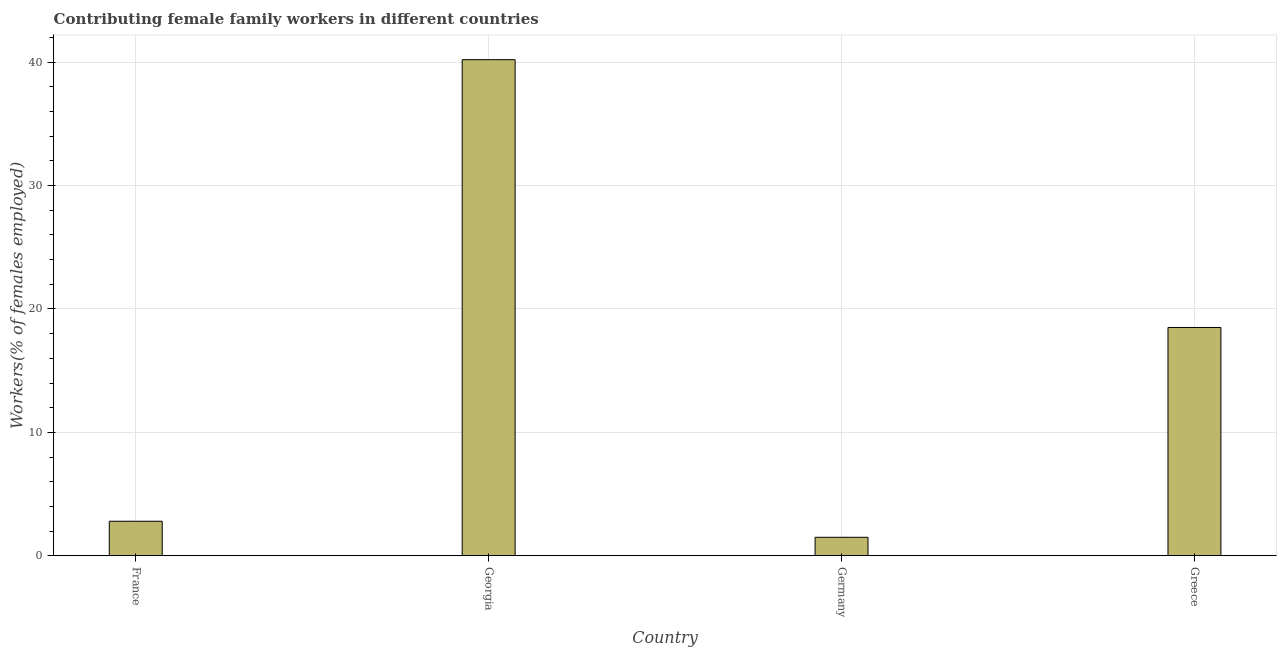What is the title of the graph?
Your response must be concise. Contributing female family workers in different countries. What is the label or title of the X-axis?
Make the answer very short. Country. What is the label or title of the Y-axis?
Give a very brief answer. Workers(% of females employed). Across all countries, what is the maximum contributing female family workers?
Offer a very short reply. 40.2. Across all countries, what is the minimum contributing female family workers?
Provide a short and direct response. 1.5. In which country was the contributing female family workers maximum?
Give a very brief answer. Georgia. What is the sum of the contributing female family workers?
Give a very brief answer. 63. What is the average contributing female family workers per country?
Your answer should be compact. 15.75. What is the median contributing female family workers?
Offer a very short reply. 10.65. What is the ratio of the contributing female family workers in France to that in Greece?
Your answer should be very brief. 0.15. Is the difference between the contributing female family workers in Germany and Greece greater than the difference between any two countries?
Your response must be concise. No. What is the difference between the highest and the second highest contributing female family workers?
Offer a terse response. 21.7. What is the difference between the highest and the lowest contributing female family workers?
Keep it short and to the point. 38.7. How many countries are there in the graph?
Offer a terse response. 4. What is the difference between two consecutive major ticks on the Y-axis?
Offer a very short reply. 10. Are the values on the major ticks of Y-axis written in scientific E-notation?
Give a very brief answer. No. What is the Workers(% of females employed) in France?
Provide a short and direct response. 2.8. What is the Workers(% of females employed) in Georgia?
Offer a very short reply. 40.2. What is the difference between the Workers(% of females employed) in France and Georgia?
Your answer should be compact. -37.4. What is the difference between the Workers(% of females employed) in France and Germany?
Your response must be concise. 1.3. What is the difference between the Workers(% of females employed) in France and Greece?
Give a very brief answer. -15.7. What is the difference between the Workers(% of females employed) in Georgia and Germany?
Provide a succinct answer. 38.7. What is the difference between the Workers(% of females employed) in Georgia and Greece?
Your answer should be very brief. 21.7. What is the difference between the Workers(% of females employed) in Germany and Greece?
Your response must be concise. -17. What is the ratio of the Workers(% of females employed) in France to that in Georgia?
Ensure brevity in your answer.  0.07. What is the ratio of the Workers(% of females employed) in France to that in Germany?
Offer a very short reply. 1.87. What is the ratio of the Workers(% of females employed) in France to that in Greece?
Keep it short and to the point. 0.15. What is the ratio of the Workers(% of females employed) in Georgia to that in Germany?
Your answer should be compact. 26.8. What is the ratio of the Workers(% of females employed) in Georgia to that in Greece?
Offer a terse response. 2.17. What is the ratio of the Workers(% of females employed) in Germany to that in Greece?
Give a very brief answer. 0.08. 